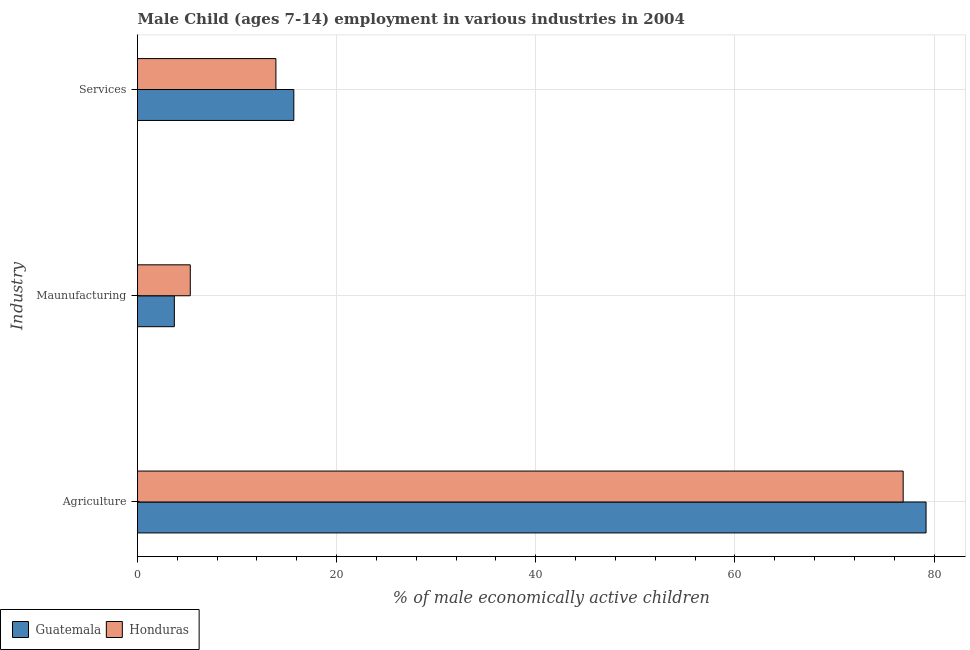How many different coloured bars are there?
Provide a succinct answer. 2. Are the number of bars per tick equal to the number of legend labels?
Provide a short and direct response. Yes. How many bars are there on the 2nd tick from the top?
Offer a terse response. 2. What is the label of the 2nd group of bars from the top?
Ensure brevity in your answer.  Maunufacturing. What is the percentage of economically active children in agriculture in Honduras?
Ensure brevity in your answer.  76.9. Across all countries, what is the maximum percentage of economically active children in agriculture?
Your response must be concise. 79.2. Across all countries, what is the minimum percentage of economically active children in services?
Provide a short and direct response. 13.9. In which country was the percentage of economically active children in agriculture maximum?
Your response must be concise. Guatemala. In which country was the percentage of economically active children in services minimum?
Your response must be concise. Honduras. What is the difference between the percentage of economically active children in agriculture in Guatemala and that in Honduras?
Keep it short and to the point. 2.3. What is the difference between the percentage of economically active children in agriculture in Honduras and the percentage of economically active children in manufacturing in Guatemala?
Provide a short and direct response. 73.2. What is the average percentage of economically active children in agriculture per country?
Ensure brevity in your answer.  78.05. What is the difference between the percentage of economically active children in agriculture and percentage of economically active children in services in Guatemala?
Provide a succinct answer. 63.5. In how many countries, is the percentage of economically active children in services greater than 28 %?
Your answer should be very brief. 0. What is the ratio of the percentage of economically active children in services in Guatemala to that in Honduras?
Keep it short and to the point. 1.13. Is the percentage of economically active children in agriculture in Honduras less than that in Guatemala?
Give a very brief answer. Yes. Is the difference between the percentage of economically active children in agriculture in Guatemala and Honduras greater than the difference between the percentage of economically active children in manufacturing in Guatemala and Honduras?
Ensure brevity in your answer.  Yes. What is the difference between the highest and the second highest percentage of economically active children in services?
Give a very brief answer. 1.8. What is the difference between the highest and the lowest percentage of economically active children in manufacturing?
Make the answer very short. 1.6. In how many countries, is the percentage of economically active children in agriculture greater than the average percentage of economically active children in agriculture taken over all countries?
Keep it short and to the point. 1. Is the sum of the percentage of economically active children in agriculture in Honduras and Guatemala greater than the maximum percentage of economically active children in services across all countries?
Ensure brevity in your answer.  Yes. What does the 1st bar from the top in Maunufacturing represents?
Provide a short and direct response. Honduras. What does the 1st bar from the bottom in Services represents?
Your answer should be compact. Guatemala. What is the difference between two consecutive major ticks on the X-axis?
Keep it short and to the point. 20. Where does the legend appear in the graph?
Provide a short and direct response. Bottom left. How are the legend labels stacked?
Your answer should be compact. Horizontal. What is the title of the graph?
Your answer should be very brief. Male Child (ages 7-14) employment in various industries in 2004. Does "Tajikistan" appear as one of the legend labels in the graph?
Your response must be concise. No. What is the label or title of the X-axis?
Your response must be concise. % of male economically active children. What is the label or title of the Y-axis?
Offer a very short reply. Industry. What is the % of male economically active children of Guatemala in Agriculture?
Give a very brief answer. 79.2. What is the % of male economically active children of Honduras in Agriculture?
Provide a short and direct response. 76.9. What is the % of male economically active children in Guatemala in Maunufacturing?
Your answer should be compact. 3.7. Across all Industry, what is the maximum % of male economically active children of Guatemala?
Offer a terse response. 79.2. Across all Industry, what is the maximum % of male economically active children of Honduras?
Offer a very short reply. 76.9. Across all Industry, what is the minimum % of male economically active children in Guatemala?
Offer a terse response. 3.7. What is the total % of male economically active children in Guatemala in the graph?
Offer a terse response. 98.6. What is the total % of male economically active children in Honduras in the graph?
Your answer should be very brief. 96.1. What is the difference between the % of male economically active children of Guatemala in Agriculture and that in Maunufacturing?
Provide a short and direct response. 75.5. What is the difference between the % of male economically active children in Honduras in Agriculture and that in Maunufacturing?
Keep it short and to the point. 71.6. What is the difference between the % of male economically active children in Guatemala in Agriculture and that in Services?
Your response must be concise. 63.5. What is the difference between the % of male economically active children of Guatemala in Agriculture and the % of male economically active children of Honduras in Maunufacturing?
Provide a succinct answer. 73.9. What is the difference between the % of male economically active children of Guatemala in Agriculture and the % of male economically active children of Honduras in Services?
Your answer should be compact. 65.3. What is the difference between the % of male economically active children of Guatemala in Maunufacturing and the % of male economically active children of Honduras in Services?
Provide a succinct answer. -10.2. What is the average % of male economically active children of Guatemala per Industry?
Provide a succinct answer. 32.87. What is the average % of male economically active children in Honduras per Industry?
Give a very brief answer. 32.03. What is the difference between the % of male economically active children in Guatemala and % of male economically active children in Honduras in Agriculture?
Your answer should be very brief. 2.3. What is the difference between the % of male economically active children of Guatemala and % of male economically active children of Honduras in Services?
Provide a succinct answer. 1.8. What is the ratio of the % of male economically active children of Guatemala in Agriculture to that in Maunufacturing?
Your answer should be very brief. 21.41. What is the ratio of the % of male economically active children in Honduras in Agriculture to that in Maunufacturing?
Your answer should be compact. 14.51. What is the ratio of the % of male economically active children of Guatemala in Agriculture to that in Services?
Offer a very short reply. 5.04. What is the ratio of the % of male economically active children of Honduras in Agriculture to that in Services?
Offer a terse response. 5.53. What is the ratio of the % of male economically active children in Guatemala in Maunufacturing to that in Services?
Make the answer very short. 0.24. What is the ratio of the % of male economically active children of Honduras in Maunufacturing to that in Services?
Keep it short and to the point. 0.38. What is the difference between the highest and the second highest % of male economically active children in Guatemala?
Offer a very short reply. 63.5. What is the difference between the highest and the second highest % of male economically active children in Honduras?
Ensure brevity in your answer.  63. What is the difference between the highest and the lowest % of male economically active children in Guatemala?
Offer a terse response. 75.5. What is the difference between the highest and the lowest % of male economically active children in Honduras?
Provide a succinct answer. 71.6. 